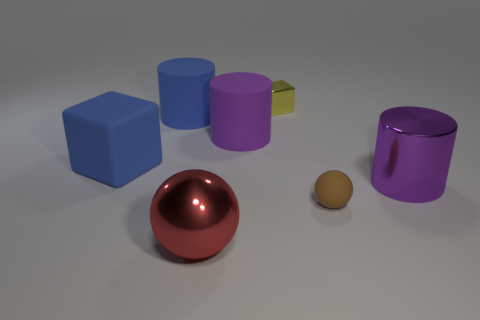What number of other things are the same color as the tiny matte sphere?
Your answer should be very brief. 0. What is the color of the big block?
Make the answer very short. Blue. What number of big red objects have the same shape as the brown matte thing?
Provide a short and direct response. 1. What number of objects are rubber cylinders or tiny brown matte spheres in front of the big blue matte cylinder?
Provide a succinct answer. 3. There is a matte block; is it the same color as the large cylinder to the left of the big metal sphere?
Keep it short and to the point. Yes. There is a metallic object that is on the left side of the tiny brown thing and to the right of the big red thing; how big is it?
Offer a terse response. Small. Are there any large objects behind the brown rubber sphere?
Provide a short and direct response. Yes. There is a large purple cylinder that is in front of the large blue block; is there a small yellow metallic block that is on the right side of it?
Offer a very short reply. No. Are there the same number of big metal cylinders to the right of the big red metallic ball and large purple metal things that are in front of the purple shiny cylinder?
Offer a very short reply. No. There is a block that is the same material as the brown object; what color is it?
Provide a succinct answer. Blue. 